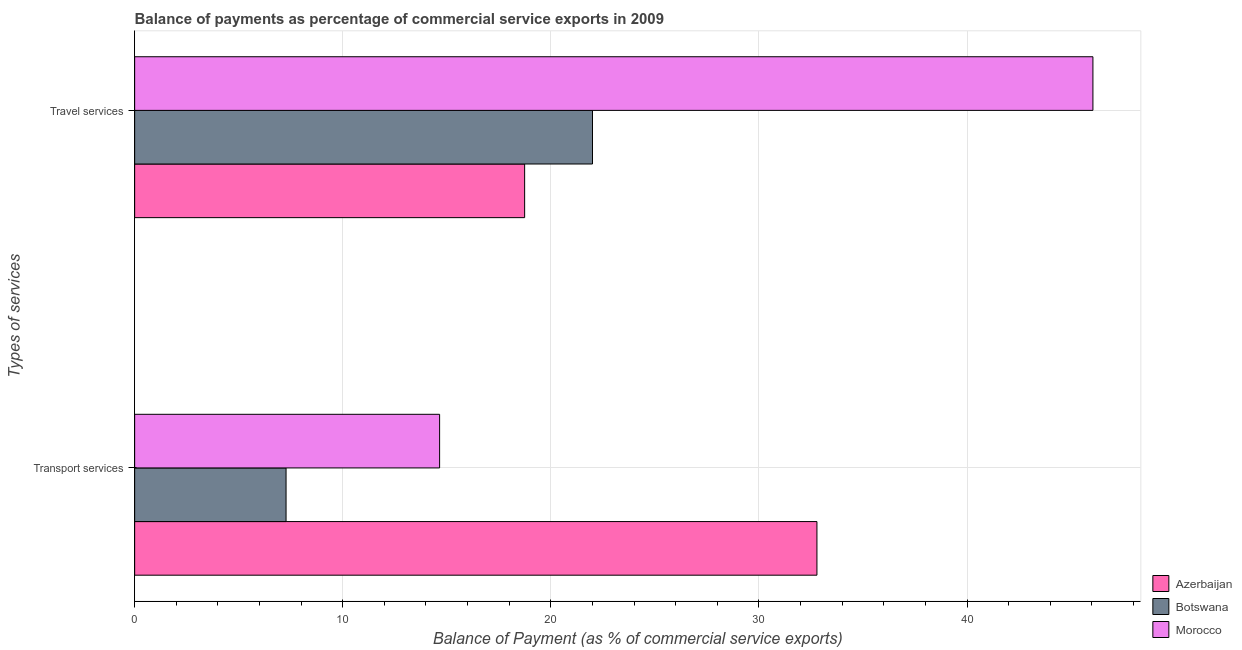How many different coloured bars are there?
Offer a terse response. 3. How many groups of bars are there?
Your answer should be compact. 2. How many bars are there on the 2nd tick from the bottom?
Offer a terse response. 3. What is the label of the 2nd group of bars from the top?
Your answer should be very brief. Transport services. What is the balance of payments of transport services in Azerbaijan?
Keep it short and to the point. 32.79. Across all countries, what is the maximum balance of payments of transport services?
Make the answer very short. 32.79. Across all countries, what is the minimum balance of payments of travel services?
Provide a succinct answer. 18.74. In which country was the balance of payments of transport services maximum?
Keep it short and to the point. Azerbaijan. In which country was the balance of payments of transport services minimum?
Make the answer very short. Botswana. What is the total balance of payments of transport services in the graph?
Provide a short and direct response. 54.72. What is the difference between the balance of payments of travel services in Morocco and that in Botswana?
Provide a short and direct response. 24.05. What is the difference between the balance of payments of transport services in Morocco and the balance of payments of travel services in Azerbaijan?
Your response must be concise. -4.09. What is the average balance of payments of transport services per country?
Offer a terse response. 18.24. What is the difference between the balance of payments of travel services and balance of payments of transport services in Botswana?
Keep it short and to the point. 14.73. What is the ratio of the balance of payments of transport services in Morocco to that in Azerbaijan?
Your response must be concise. 0.45. What does the 3rd bar from the top in Travel services represents?
Keep it short and to the point. Azerbaijan. What does the 2nd bar from the bottom in Travel services represents?
Give a very brief answer. Botswana. How many bars are there?
Your answer should be very brief. 6. What is the difference between two consecutive major ticks on the X-axis?
Offer a very short reply. 10. Are the values on the major ticks of X-axis written in scientific E-notation?
Make the answer very short. No. Does the graph contain any zero values?
Make the answer very short. No. Where does the legend appear in the graph?
Give a very brief answer. Bottom right. What is the title of the graph?
Provide a succinct answer. Balance of payments as percentage of commercial service exports in 2009. Does "Bermuda" appear as one of the legend labels in the graph?
Provide a short and direct response. No. What is the label or title of the X-axis?
Your answer should be compact. Balance of Payment (as % of commercial service exports). What is the label or title of the Y-axis?
Ensure brevity in your answer.  Types of services. What is the Balance of Payment (as % of commercial service exports) in Azerbaijan in Transport services?
Offer a terse response. 32.79. What is the Balance of Payment (as % of commercial service exports) of Botswana in Transport services?
Make the answer very short. 7.28. What is the Balance of Payment (as % of commercial service exports) in Morocco in Transport services?
Provide a short and direct response. 14.66. What is the Balance of Payment (as % of commercial service exports) in Azerbaijan in Travel services?
Give a very brief answer. 18.74. What is the Balance of Payment (as % of commercial service exports) of Botswana in Travel services?
Offer a terse response. 22. What is the Balance of Payment (as % of commercial service exports) in Morocco in Travel services?
Offer a very short reply. 46.05. Across all Types of services, what is the maximum Balance of Payment (as % of commercial service exports) of Azerbaijan?
Your answer should be compact. 32.79. Across all Types of services, what is the maximum Balance of Payment (as % of commercial service exports) in Botswana?
Your answer should be compact. 22. Across all Types of services, what is the maximum Balance of Payment (as % of commercial service exports) of Morocco?
Ensure brevity in your answer.  46.05. Across all Types of services, what is the minimum Balance of Payment (as % of commercial service exports) in Azerbaijan?
Your answer should be compact. 18.74. Across all Types of services, what is the minimum Balance of Payment (as % of commercial service exports) of Botswana?
Give a very brief answer. 7.28. Across all Types of services, what is the minimum Balance of Payment (as % of commercial service exports) of Morocco?
Your response must be concise. 14.66. What is the total Balance of Payment (as % of commercial service exports) in Azerbaijan in the graph?
Offer a terse response. 51.53. What is the total Balance of Payment (as % of commercial service exports) in Botswana in the graph?
Your answer should be compact. 29.28. What is the total Balance of Payment (as % of commercial service exports) of Morocco in the graph?
Your answer should be compact. 60.71. What is the difference between the Balance of Payment (as % of commercial service exports) of Azerbaijan in Transport services and that in Travel services?
Provide a succinct answer. 14.05. What is the difference between the Balance of Payment (as % of commercial service exports) in Botswana in Transport services and that in Travel services?
Offer a terse response. -14.73. What is the difference between the Balance of Payment (as % of commercial service exports) in Morocco in Transport services and that in Travel services?
Offer a terse response. -31.4. What is the difference between the Balance of Payment (as % of commercial service exports) of Azerbaijan in Transport services and the Balance of Payment (as % of commercial service exports) of Botswana in Travel services?
Your answer should be compact. 10.79. What is the difference between the Balance of Payment (as % of commercial service exports) of Azerbaijan in Transport services and the Balance of Payment (as % of commercial service exports) of Morocco in Travel services?
Provide a short and direct response. -13.26. What is the difference between the Balance of Payment (as % of commercial service exports) of Botswana in Transport services and the Balance of Payment (as % of commercial service exports) of Morocco in Travel services?
Provide a short and direct response. -38.78. What is the average Balance of Payment (as % of commercial service exports) in Azerbaijan per Types of services?
Provide a succinct answer. 25.77. What is the average Balance of Payment (as % of commercial service exports) in Botswana per Types of services?
Offer a very short reply. 14.64. What is the average Balance of Payment (as % of commercial service exports) of Morocco per Types of services?
Ensure brevity in your answer.  30.35. What is the difference between the Balance of Payment (as % of commercial service exports) of Azerbaijan and Balance of Payment (as % of commercial service exports) of Botswana in Transport services?
Ensure brevity in your answer.  25.51. What is the difference between the Balance of Payment (as % of commercial service exports) of Azerbaijan and Balance of Payment (as % of commercial service exports) of Morocco in Transport services?
Provide a succinct answer. 18.13. What is the difference between the Balance of Payment (as % of commercial service exports) in Botswana and Balance of Payment (as % of commercial service exports) in Morocco in Transport services?
Your answer should be very brief. -7.38. What is the difference between the Balance of Payment (as % of commercial service exports) in Azerbaijan and Balance of Payment (as % of commercial service exports) in Botswana in Travel services?
Your answer should be very brief. -3.26. What is the difference between the Balance of Payment (as % of commercial service exports) in Azerbaijan and Balance of Payment (as % of commercial service exports) in Morocco in Travel services?
Keep it short and to the point. -27.31. What is the difference between the Balance of Payment (as % of commercial service exports) of Botswana and Balance of Payment (as % of commercial service exports) of Morocco in Travel services?
Make the answer very short. -24.05. What is the ratio of the Balance of Payment (as % of commercial service exports) in Azerbaijan in Transport services to that in Travel services?
Provide a short and direct response. 1.75. What is the ratio of the Balance of Payment (as % of commercial service exports) of Botswana in Transport services to that in Travel services?
Make the answer very short. 0.33. What is the ratio of the Balance of Payment (as % of commercial service exports) of Morocco in Transport services to that in Travel services?
Provide a succinct answer. 0.32. What is the difference between the highest and the second highest Balance of Payment (as % of commercial service exports) in Azerbaijan?
Provide a short and direct response. 14.05. What is the difference between the highest and the second highest Balance of Payment (as % of commercial service exports) in Botswana?
Provide a succinct answer. 14.73. What is the difference between the highest and the second highest Balance of Payment (as % of commercial service exports) of Morocco?
Give a very brief answer. 31.4. What is the difference between the highest and the lowest Balance of Payment (as % of commercial service exports) in Azerbaijan?
Your answer should be compact. 14.05. What is the difference between the highest and the lowest Balance of Payment (as % of commercial service exports) of Botswana?
Make the answer very short. 14.73. What is the difference between the highest and the lowest Balance of Payment (as % of commercial service exports) in Morocco?
Give a very brief answer. 31.4. 